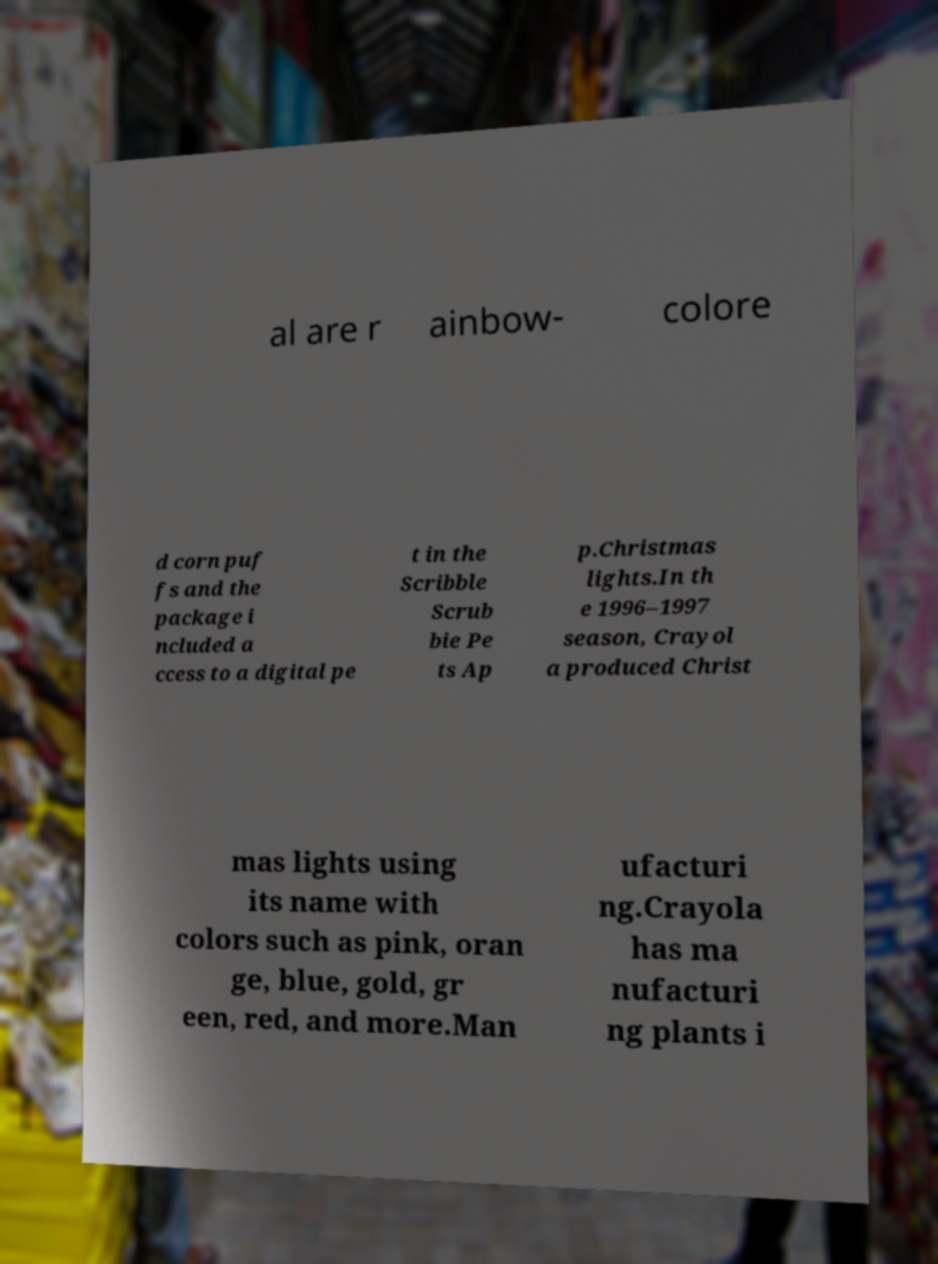Please identify and transcribe the text found in this image. al are r ainbow- colore d corn puf fs and the package i ncluded a ccess to a digital pe t in the Scribble Scrub bie Pe ts Ap p.Christmas lights.In th e 1996–1997 season, Crayol a produced Christ mas lights using its name with colors such as pink, oran ge, blue, gold, gr een, red, and more.Man ufacturi ng.Crayola has ma nufacturi ng plants i 